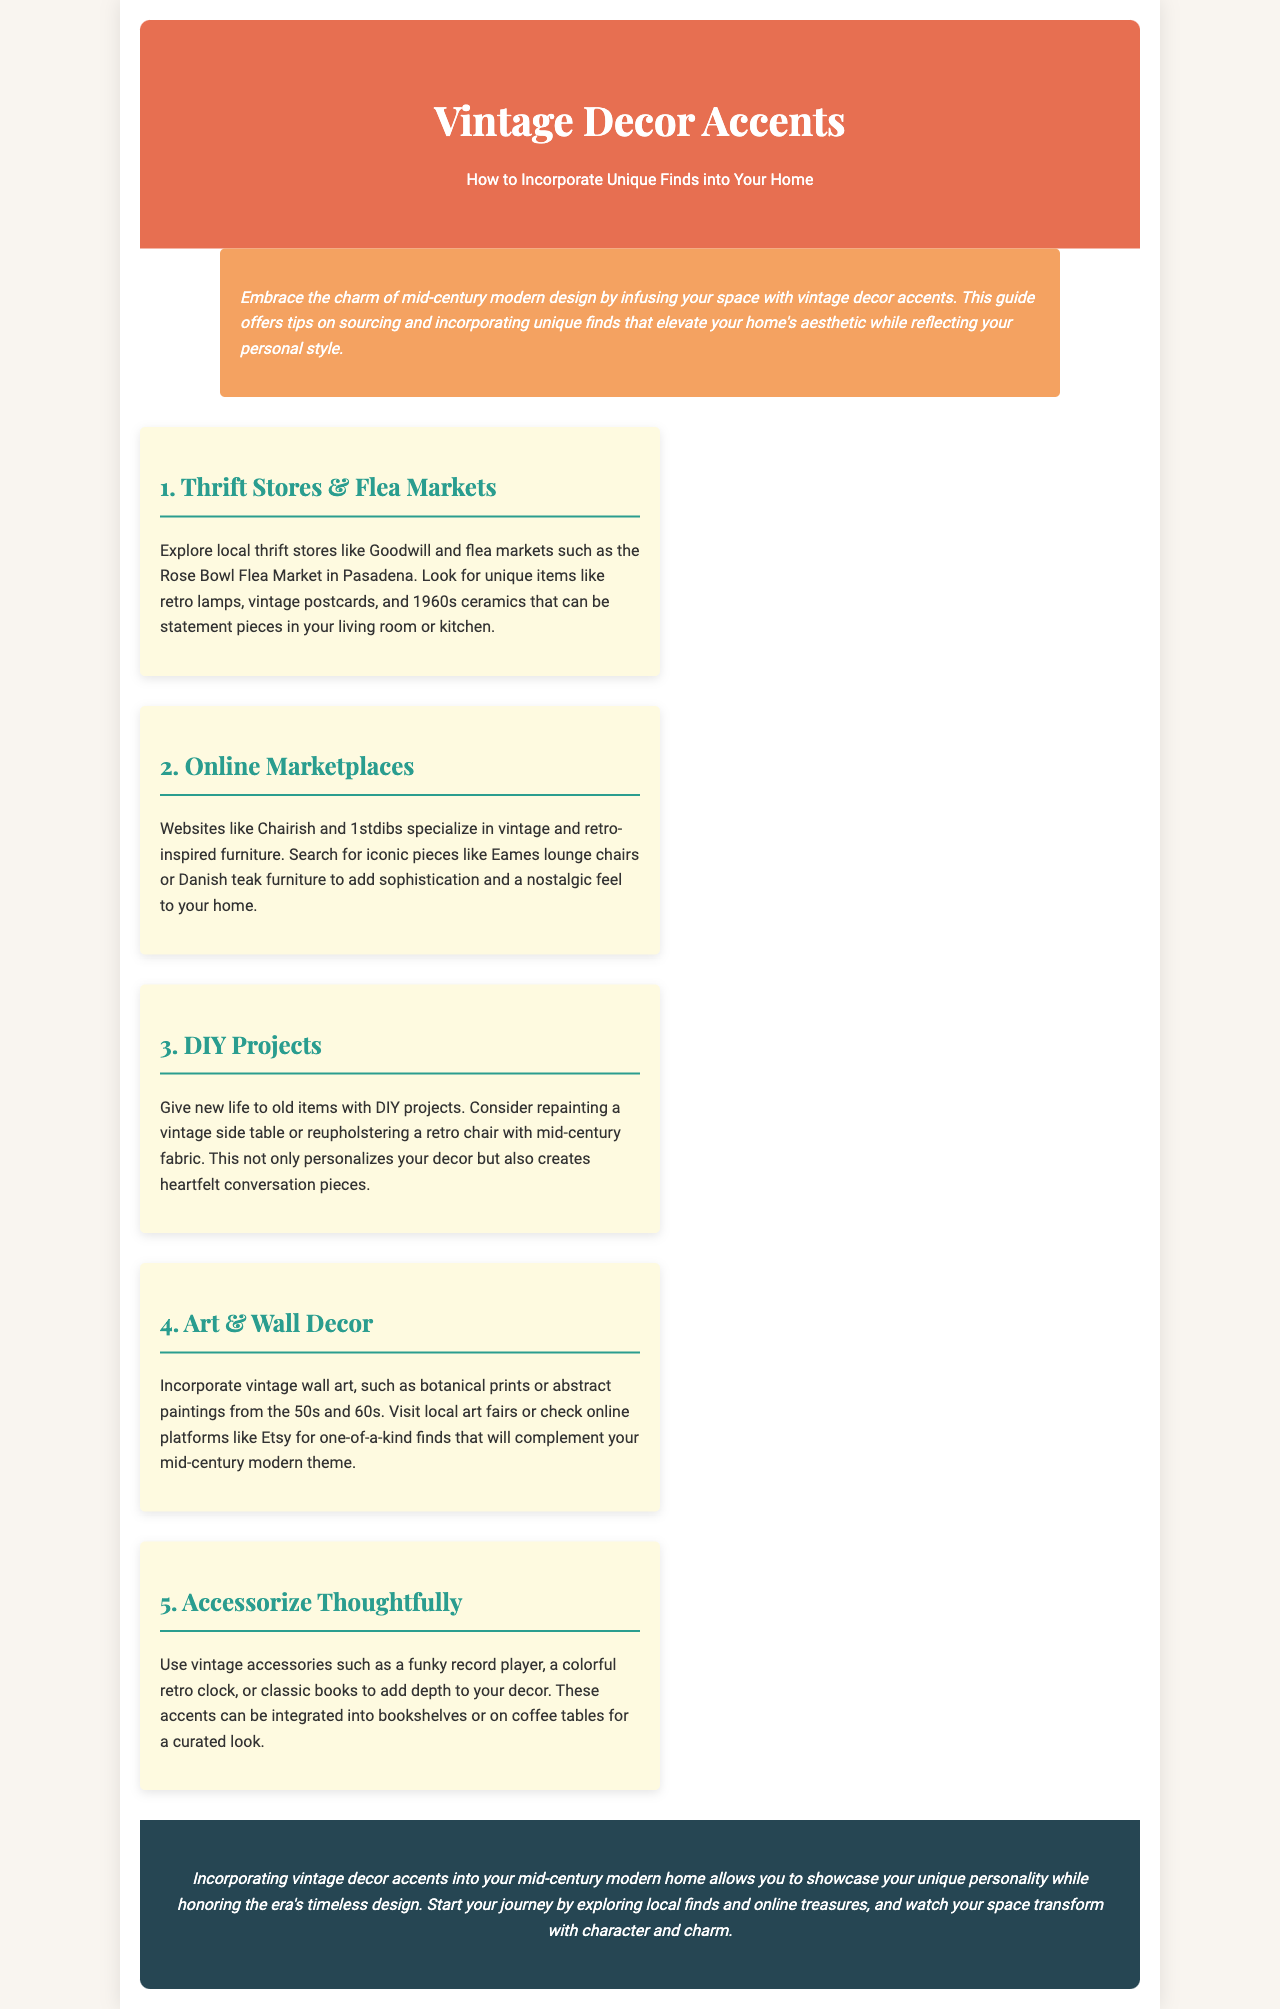what is the title of the brochure? The title is presented prominently at the top of the document, indicating the subject matter.
Answer: Vintage Decor Accents what is emphasized in the introduction? The introduction highlights the charm of mid-century modern design and the purpose of the guide related to decor accents.
Answer: Embrace the charm of mid-century modern design how many sections are outlined in the content? The document structures its content into several distinct categories, which can be counted.
Answer: 5 what type of items can you find at thrift stores and flea markets? The section mentions specific types of items that are recommended for exploration at these venues.
Answer: Retro lamps, vintage postcards, 1960s ceramics what are two online marketplaces mentioned? The document lists specific online platforms where vintage and retro-inspired furniture can be sourced.
Answer: Chairish and 1stdibs what is a suggested DIY project mentioned? The section on DIY projects provides examples of activities to engage with old items, asking for a specific example.
Answer: Reupholstering a retro chair what type of wall art is suggested for incorporation? The section outlines certain styles of art that complement the mid-century modern theme.
Answer: Botanical prints or abstract paintings which accessory is suggested to add depth to decor? The conclusion provides suggestions for using certain types of accessories to enhance home decor.
Answer: Funky record player 